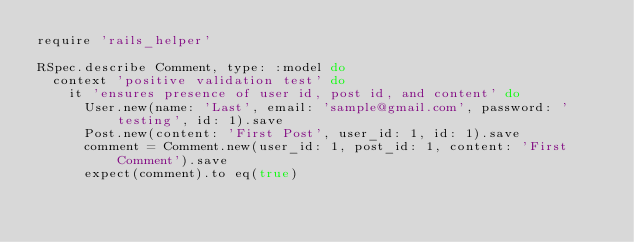<code> <loc_0><loc_0><loc_500><loc_500><_Ruby_>require 'rails_helper'

RSpec.describe Comment, type: :model do
  context 'positive validation test' do
    it 'ensures presence of user id, post id, and content' do
      User.new(name: 'Last', email: 'sample@gmail.com', password: 'testing', id: 1).save
      Post.new(content: 'First Post', user_id: 1, id: 1).save
      comment = Comment.new(user_id: 1, post_id: 1, content: 'First Comment').save
      expect(comment).to eq(true)</code> 